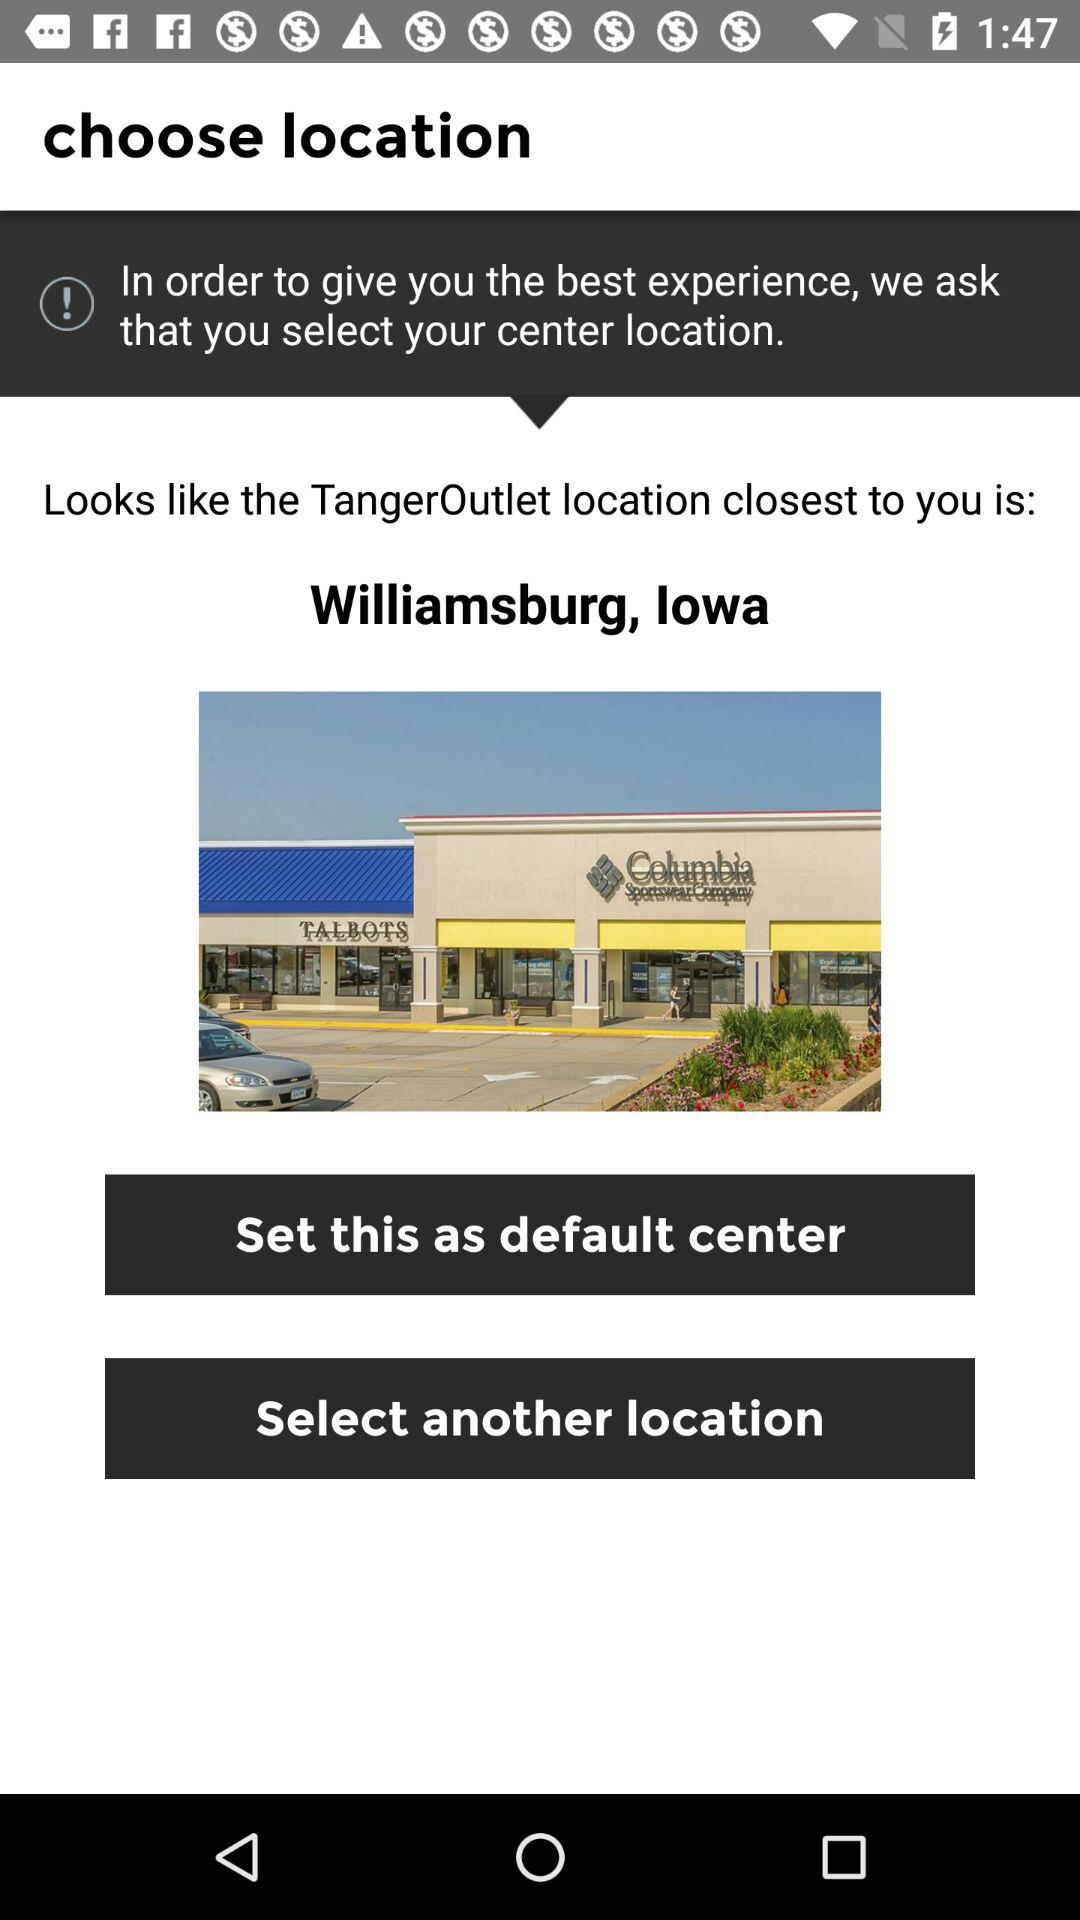What is the current location of the "TangerOutlet"? The current location of the "TangerOutlet" is Williamsburg, Iowa. 